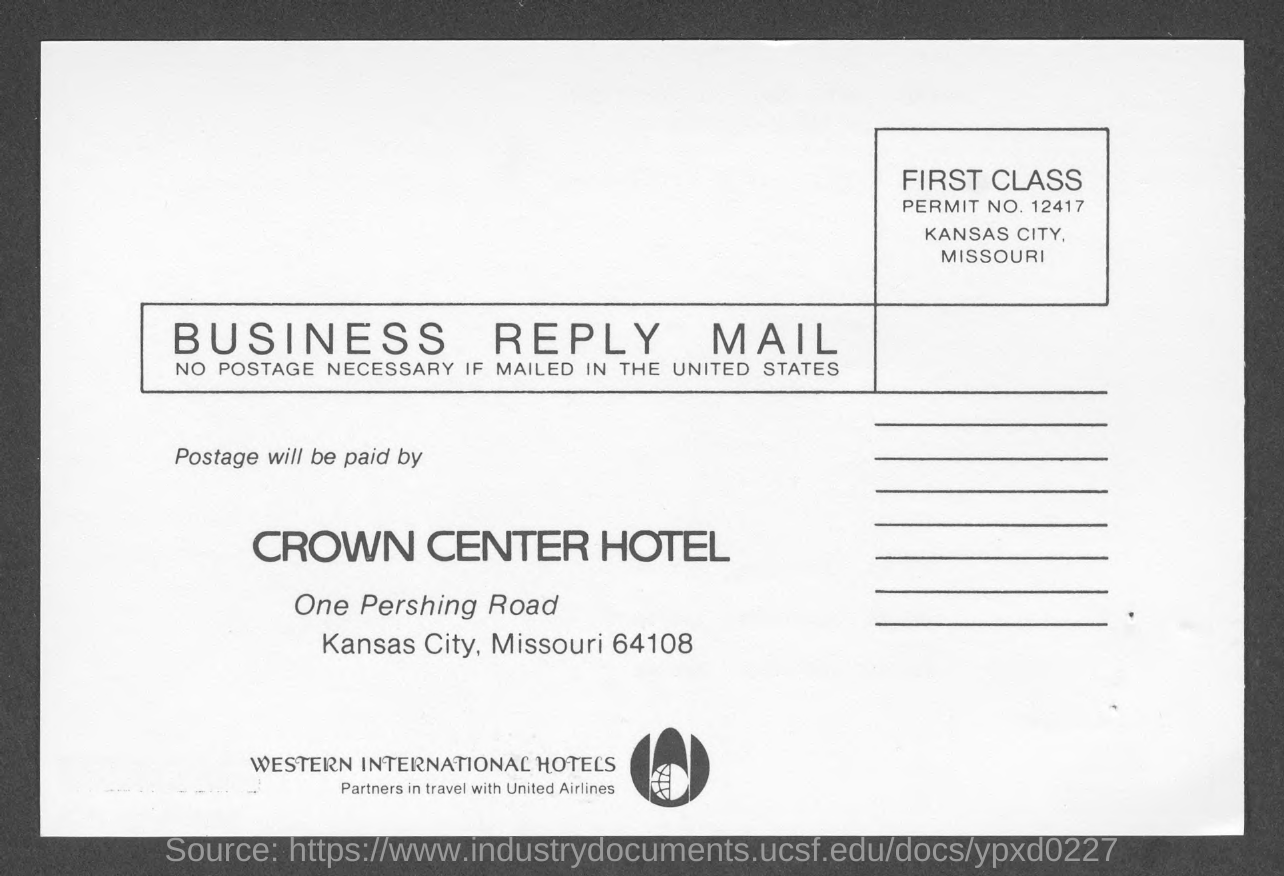Mention a couple of crucial points in this snapshot. The Crown Center Hotel is located in Kansas City. What is the permit number? 